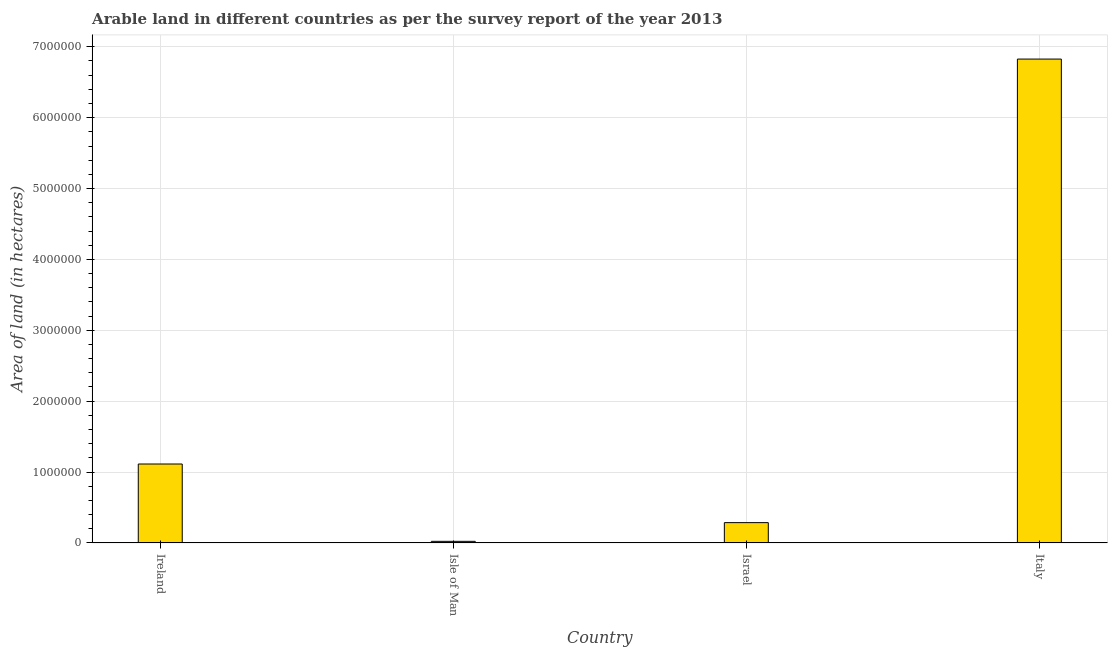What is the title of the graph?
Make the answer very short. Arable land in different countries as per the survey report of the year 2013. What is the label or title of the X-axis?
Give a very brief answer. Country. What is the label or title of the Y-axis?
Give a very brief answer. Area of land (in hectares). What is the area of land in Israel?
Offer a very short reply. 2.86e+05. Across all countries, what is the maximum area of land?
Your answer should be compact. 6.83e+06. Across all countries, what is the minimum area of land?
Make the answer very short. 2.19e+04. In which country was the area of land minimum?
Make the answer very short. Isle of Man. What is the sum of the area of land?
Offer a terse response. 8.25e+06. What is the difference between the area of land in Ireland and Isle of Man?
Keep it short and to the point. 1.09e+06. What is the average area of land per country?
Ensure brevity in your answer.  2.06e+06. What is the median area of land?
Keep it short and to the point. 6.99e+05. What is the ratio of the area of land in Isle of Man to that in Italy?
Your answer should be compact. 0. What is the difference between the highest and the second highest area of land?
Your answer should be very brief. 5.71e+06. What is the difference between the highest and the lowest area of land?
Your answer should be compact. 6.81e+06. In how many countries, is the area of land greater than the average area of land taken over all countries?
Give a very brief answer. 1. What is the difference between two consecutive major ticks on the Y-axis?
Keep it short and to the point. 1.00e+06. Are the values on the major ticks of Y-axis written in scientific E-notation?
Your answer should be very brief. No. What is the Area of land (in hectares) in Ireland?
Offer a terse response. 1.11e+06. What is the Area of land (in hectares) in Isle of Man?
Your response must be concise. 2.19e+04. What is the Area of land (in hectares) of Israel?
Provide a short and direct response. 2.86e+05. What is the Area of land (in hectares) in Italy?
Your answer should be compact. 6.83e+06. What is the difference between the Area of land (in hectares) in Ireland and Isle of Man?
Your answer should be compact. 1.09e+06. What is the difference between the Area of land (in hectares) in Ireland and Israel?
Keep it short and to the point. 8.27e+05. What is the difference between the Area of land (in hectares) in Ireland and Italy?
Make the answer very short. -5.71e+06. What is the difference between the Area of land (in hectares) in Isle of Man and Israel?
Your answer should be compact. -2.64e+05. What is the difference between the Area of land (in hectares) in Isle of Man and Italy?
Provide a succinct answer. -6.81e+06. What is the difference between the Area of land (in hectares) in Israel and Italy?
Keep it short and to the point. -6.54e+06. What is the ratio of the Area of land (in hectares) in Ireland to that in Isle of Man?
Provide a short and direct response. 50.82. What is the ratio of the Area of land (in hectares) in Ireland to that in Israel?
Provide a short and direct response. 3.89. What is the ratio of the Area of land (in hectares) in Ireland to that in Italy?
Your answer should be very brief. 0.16. What is the ratio of the Area of land (in hectares) in Isle of Man to that in Israel?
Offer a terse response. 0.08. What is the ratio of the Area of land (in hectares) in Isle of Man to that in Italy?
Give a very brief answer. 0. What is the ratio of the Area of land (in hectares) in Israel to that in Italy?
Provide a succinct answer. 0.04. 